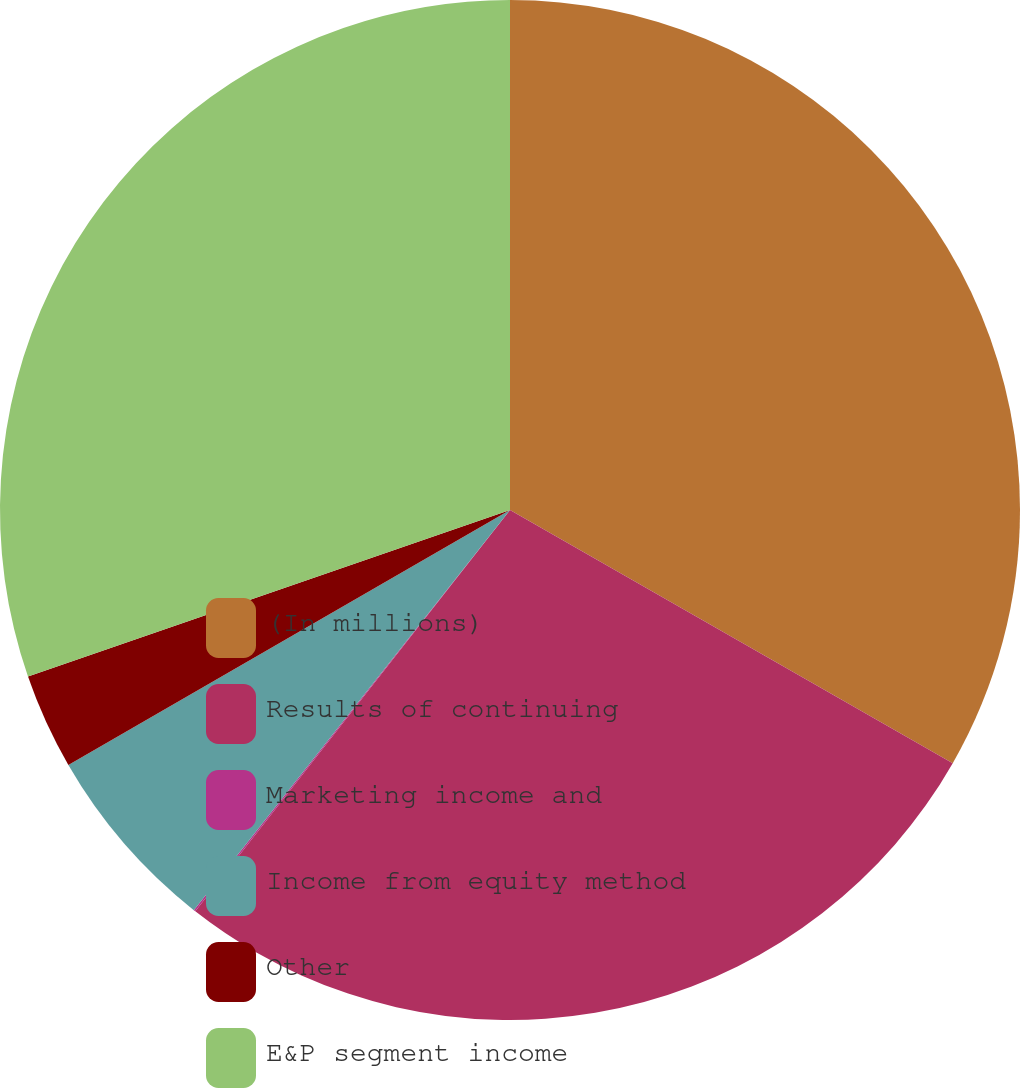Convert chart. <chart><loc_0><loc_0><loc_500><loc_500><pie_chart><fcel>(In millions)<fcel>Results of continuing<fcel>Marketing income and<fcel>Income from equity method<fcel>Other<fcel>E&P segment income<nl><fcel>33.27%<fcel>27.32%<fcel>0.06%<fcel>6.02%<fcel>3.04%<fcel>30.3%<nl></chart> 